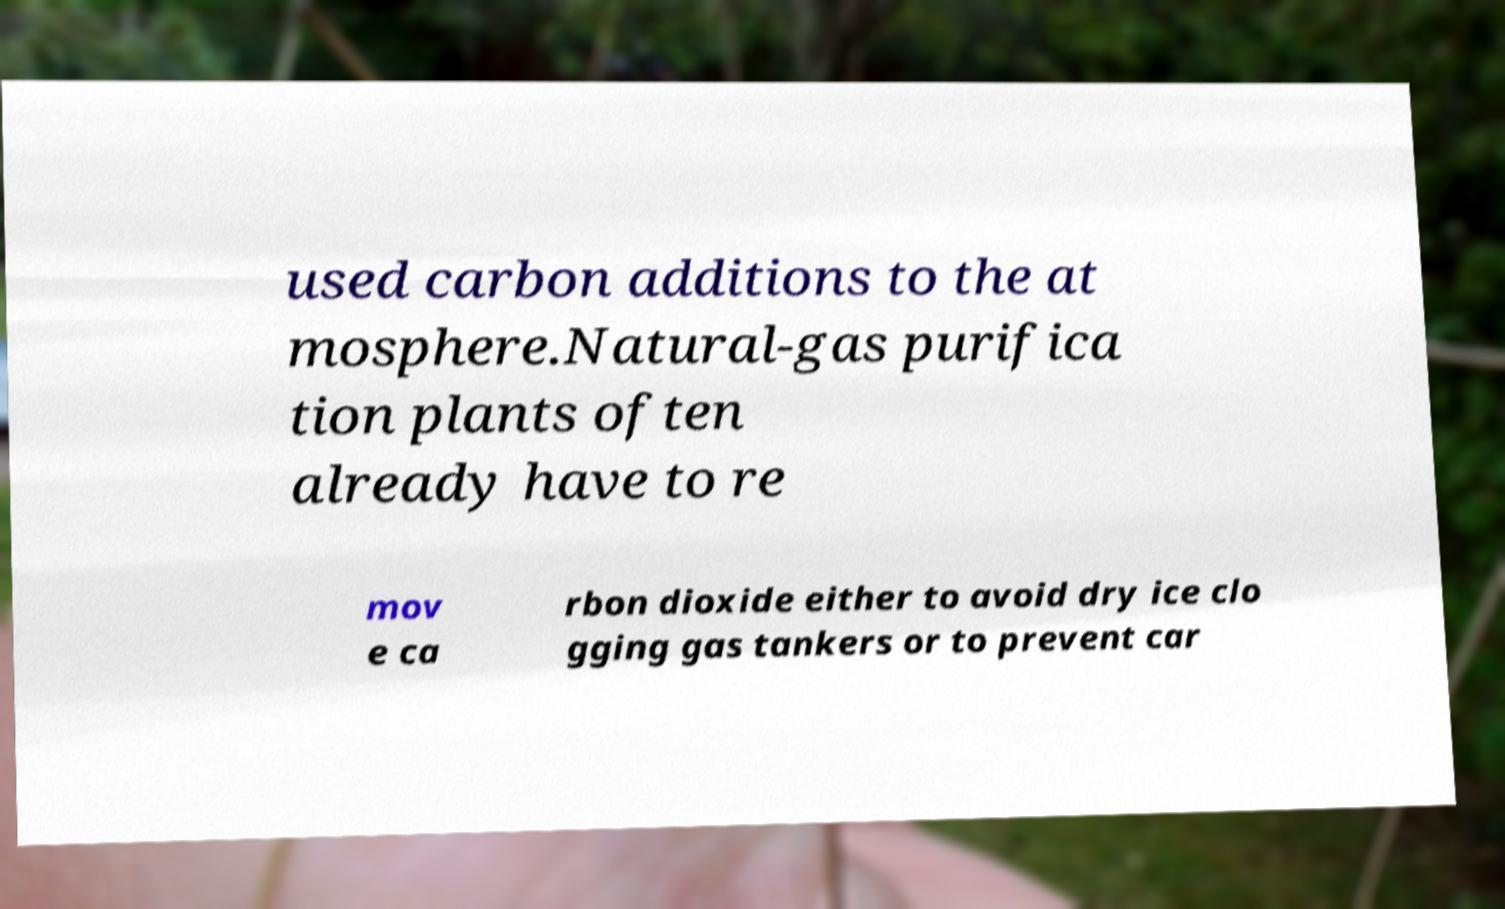Could you assist in decoding the text presented in this image and type it out clearly? used carbon additions to the at mosphere.Natural-gas purifica tion plants often already have to re mov e ca rbon dioxide either to avoid dry ice clo gging gas tankers or to prevent car 